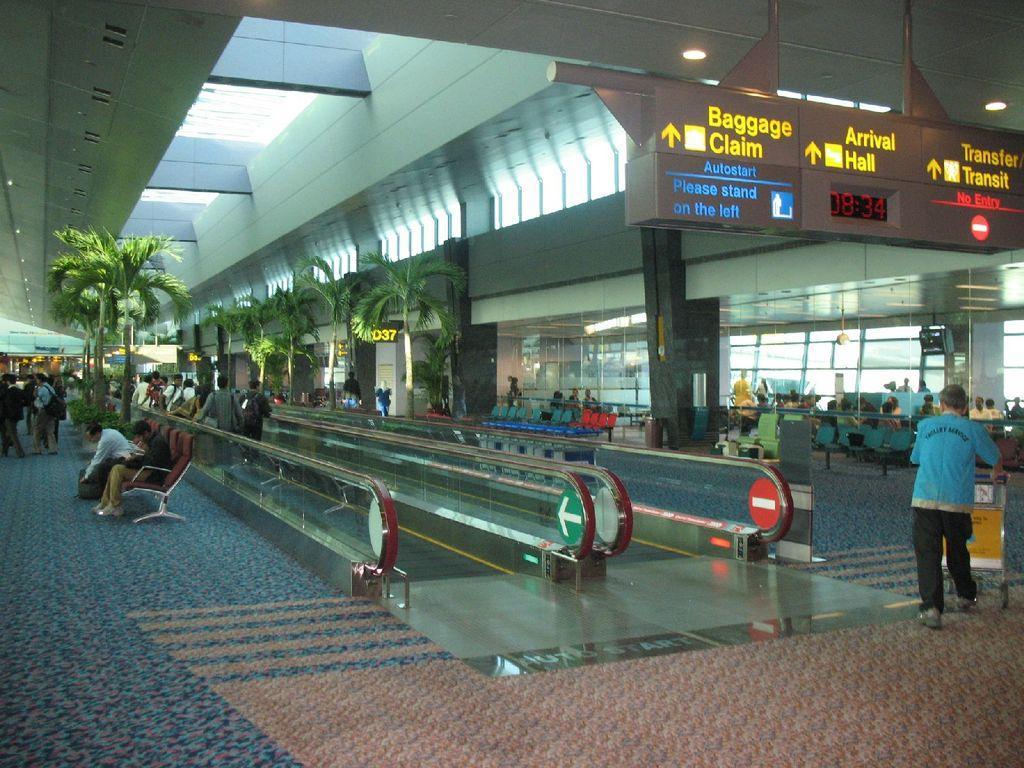Can you describe this image briefly? In this image there are persons sitting and walking, there are trees, there are boards with some text written on it, there are empty chairs, windows, pillars and there are lights. 